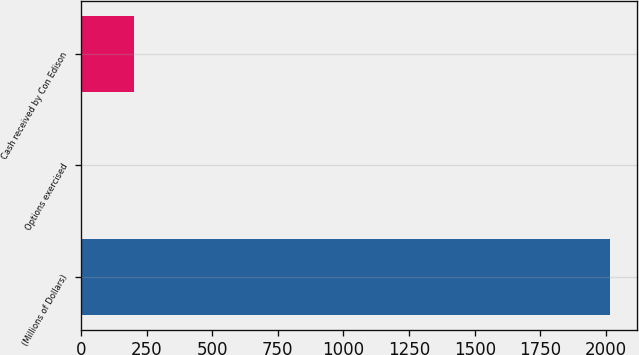<chart> <loc_0><loc_0><loc_500><loc_500><bar_chart><fcel>(Millions of Dollars)<fcel>Options exercised<fcel>Cash received by Con Edison<nl><fcel>2016<fcel>2<fcel>203.4<nl></chart> 